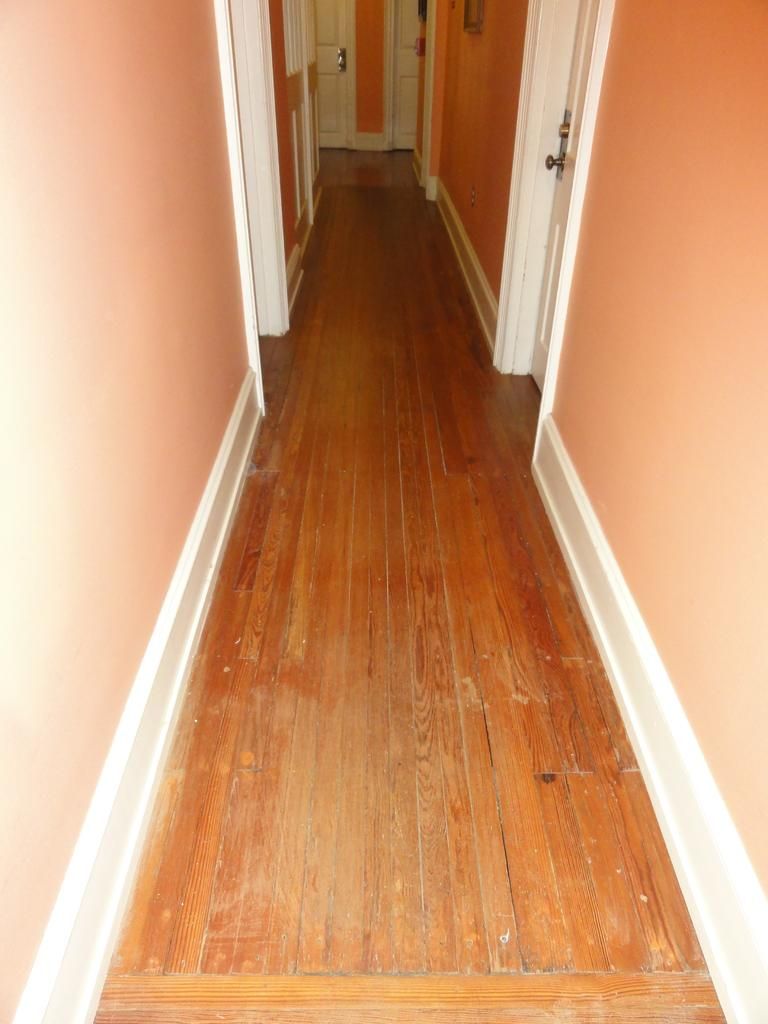What type of flooring is visible in the image? There is a wooden floor in the image. What type of architectural feature can be seen in the image? There are doors in the image. Can you describe the object attached to the wall at the top of the image? Unfortunately, the provided facts do not give enough information to describe the object attached to the wall. What type of chair is placed in the middle of the room in the image? There is no chair present in the image. What type of shock can be seen coming from the object attached to the wall in the image? There is no shock present in the image, and the object attached to the wall is not described in enough detail to determine if it could produce a shock. 